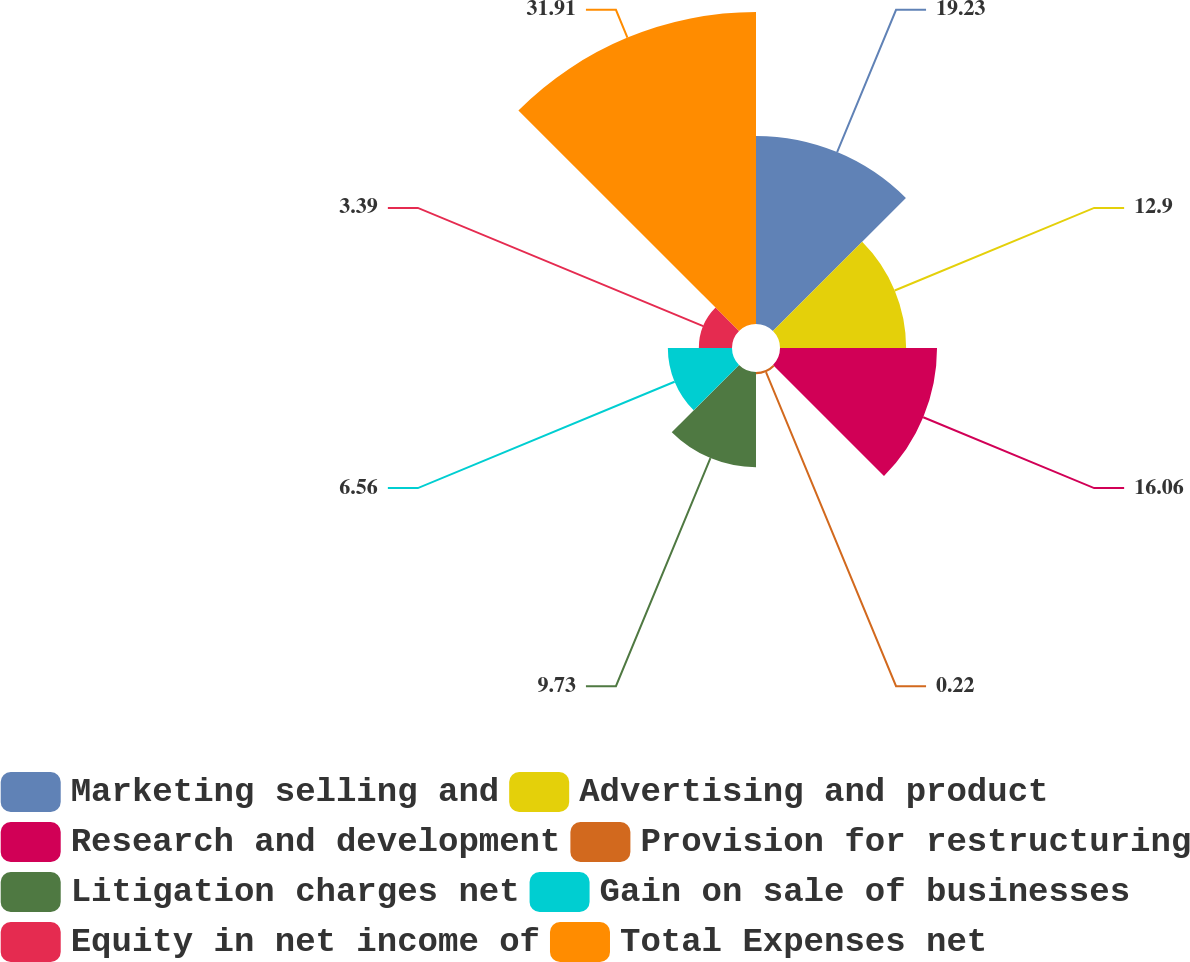<chart> <loc_0><loc_0><loc_500><loc_500><pie_chart><fcel>Marketing selling and<fcel>Advertising and product<fcel>Research and development<fcel>Provision for restructuring<fcel>Litigation charges net<fcel>Gain on sale of businesses<fcel>Equity in net income of<fcel>Total Expenses net<nl><fcel>19.23%<fcel>12.9%<fcel>16.06%<fcel>0.22%<fcel>9.73%<fcel>6.56%<fcel>3.39%<fcel>31.91%<nl></chart> 